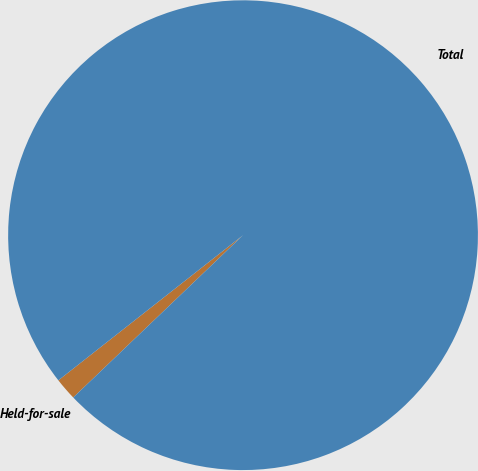<chart> <loc_0><loc_0><loc_500><loc_500><pie_chart><fcel>Held-for-sale<fcel>Total<nl><fcel>1.54%<fcel>98.46%<nl></chart> 